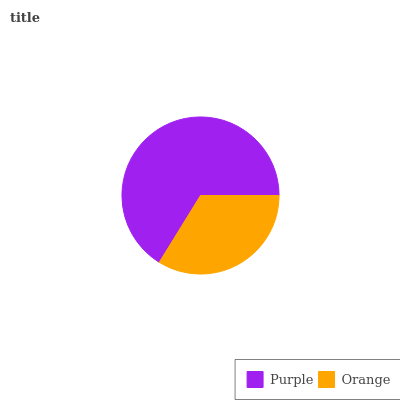Is Orange the minimum?
Answer yes or no. Yes. Is Purple the maximum?
Answer yes or no. Yes. Is Orange the maximum?
Answer yes or no. No. Is Purple greater than Orange?
Answer yes or no. Yes. Is Orange less than Purple?
Answer yes or no. Yes. Is Orange greater than Purple?
Answer yes or no. No. Is Purple less than Orange?
Answer yes or no. No. Is Purple the high median?
Answer yes or no. Yes. Is Orange the low median?
Answer yes or no. Yes. Is Orange the high median?
Answer yes or no. No. Is Purple the low median?
Answer yes or no. No. 